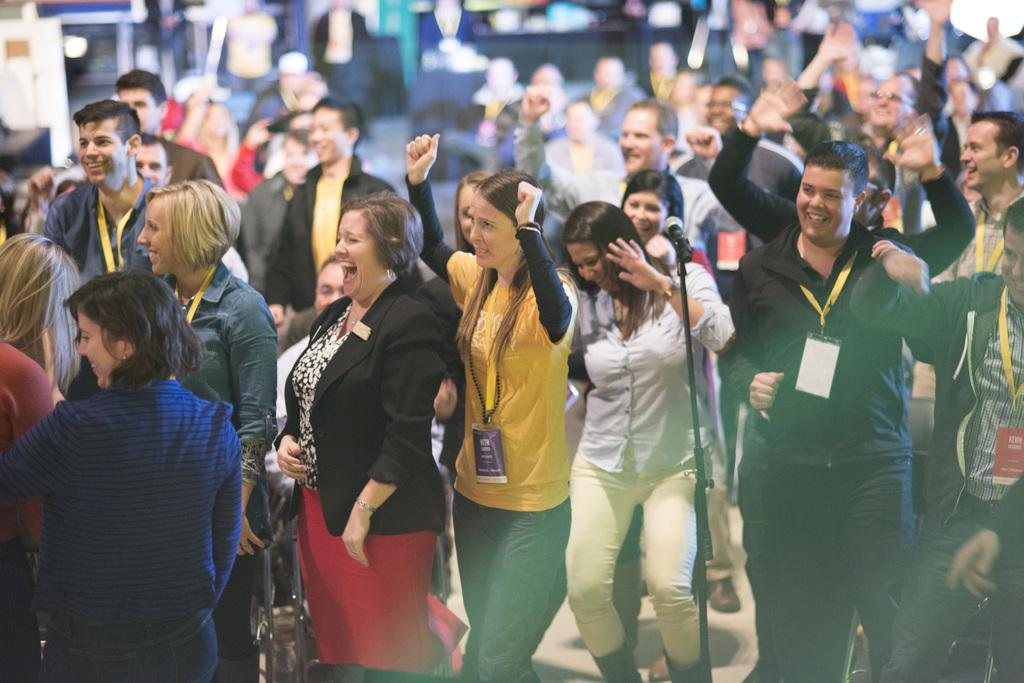What is happening in the center of the image? There are many people standing in the center of the image. What is the mood or emotion of the people in the image? The people are laughing. Can you describe any objects present in the image? There is a mic placed on a stand. How many mice can be seen running around the mic stand in the image? There are no mice present in the image. What type of cork is being used to hold the mic stand in place? There is no cork mentioned or visible in the image. 